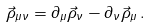Convert formula to latex. <formula><loc_0><loc_0><loc_500><loc_500>\vec { \rho } _ { \mu \nu } = \partial _ { \mu } \vec { \rho } _ { \nu } - \partial _ { \nu } \vec { \rho } _ { \mu } \, .</formula> 